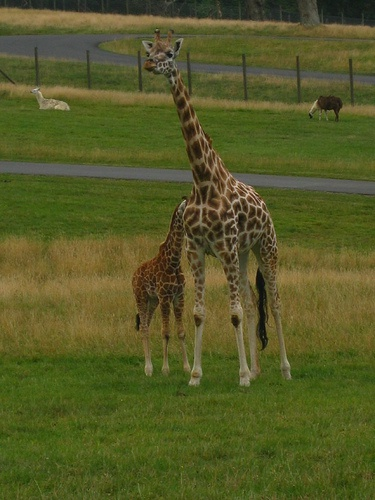Describe the objects in this image and their specific colors. I can see giraffe in black, olive, and gray tones and giraffe in black, olive, and maroon tones in this image. 